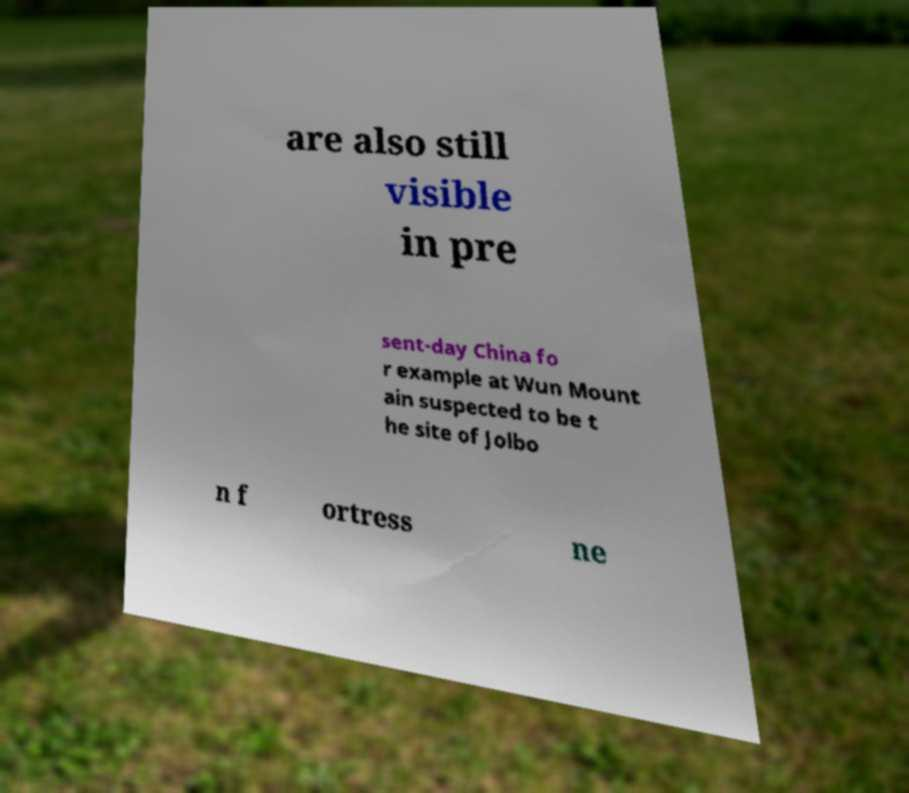I need the written content from this picture converted into text. Can you do that? are also still visible in pre sent-day China fo r example at Wun Mount ain suspected to be t he site of Jolbo n f ortress ne 